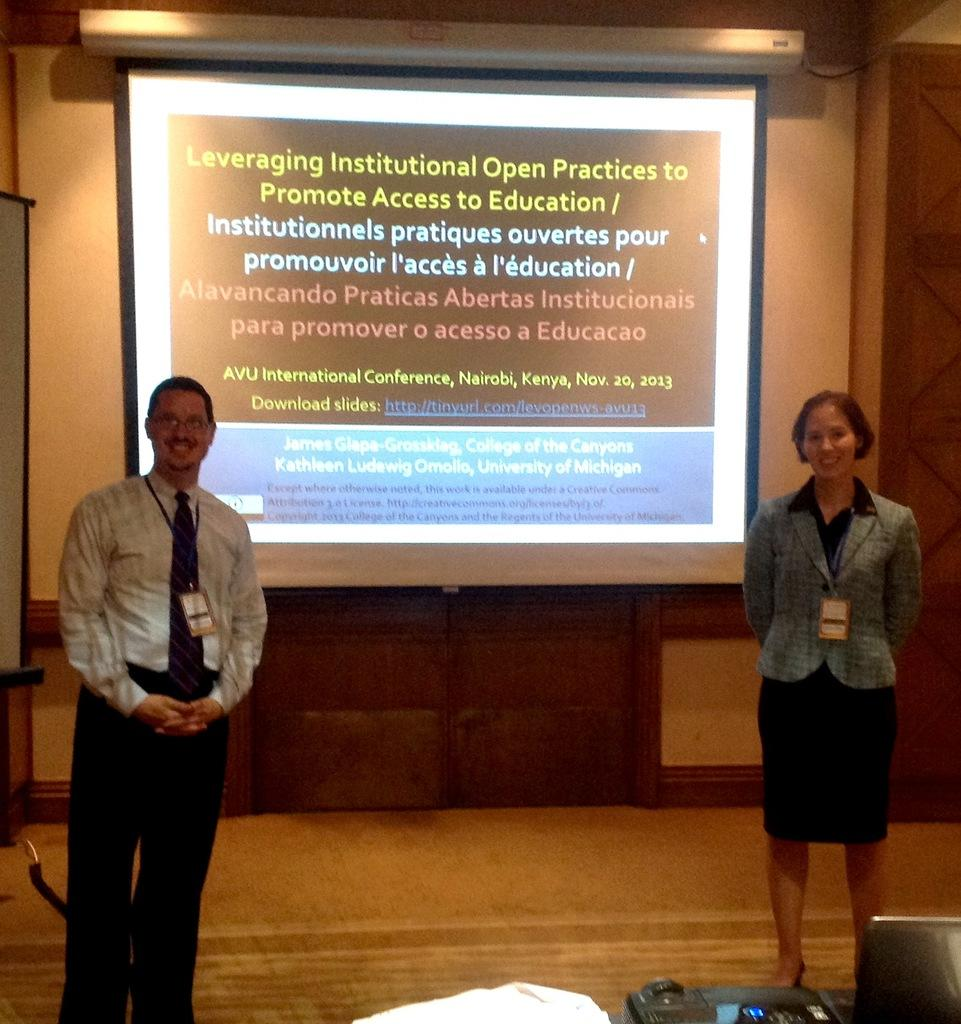How many people are in the image? There are two people in the image, a man and a woman. What are the man and the woman doing in the image? Both the man and the woman are standing and smiling. What electronic device is visible in the image? There is a laptop in the image. What type of display is present in the image? There are projector screens in the image. What can be seen in the background of the image? There is a wall in the background of the image. What type of dirt can be seen on the fairies' wings in the image? There are no fairies present in the image, and therefore no dirt on their wings. How many family members are visible in the image? The image only shows a man and a woman, so it is not possible to determine the number of family members. 